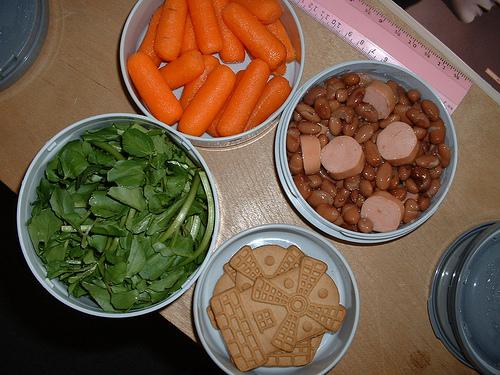Are all the dishes vegetarian?
Write a very short answer. No. Are those bananas on the bowl?
Keep it brief. No. How many containers are there?
Answer briefly. 4. What is the treat in this lunch?
Answer briefly. Cookies. Are there any raw vegetables?
Keep it brief. Yes. How many plates only contain vegetables?
Give a very brief answer. 2. 